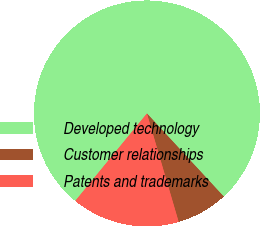Convert chart to OTSL. <chart><loc_0><loc_0><loc_500><loc_500><pie_chart><fcel>Developed technology<fcel>Customer relationships<fcel>Patents and trademarks<nl><fcel>77.2%<fcel>7.34%<fcel>15.46%<nl></chart> 